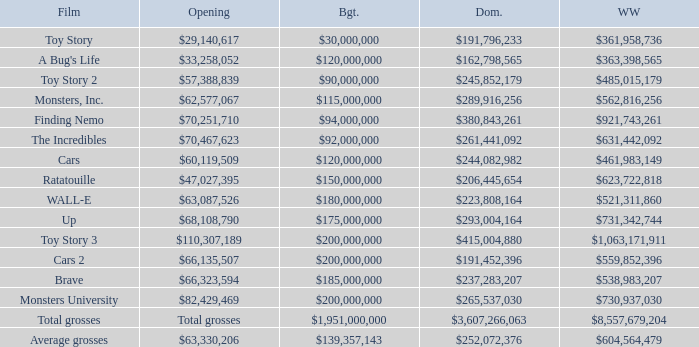WHAT IS THE WORLDWIDE BOX OFFICE FOR BRAVE? $538,983,207. 